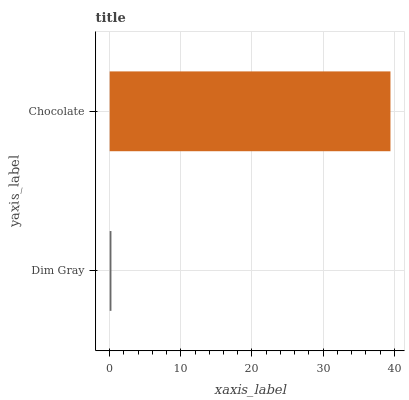Is Dim Gray the minimum?
Answer yes or no. Yes. Is Chocolate the maximum?
Answer yes or no. Yes. Is Chocolate the minimum?
Answer yes or no. No. Is Chocolate greater than Dim Gray?
Answer yes or no. Yes. Is Dim Gray less than Chocolate?
Answer yes or no. Yes. Is Dim Gray greater than Chocolate?
Answer yes or no. No. Is Chocolate less than Dim Gray?
Answer yes or no. No. Is Chocolate the high median?
Answer yes or no. Yes. Is Dim Gray the low median?
Answer yes or no. Yes. Is Dim Gray the high median?
Answer yes or no. No. Is Chocolate the low median?
Answer yes or no. No. 